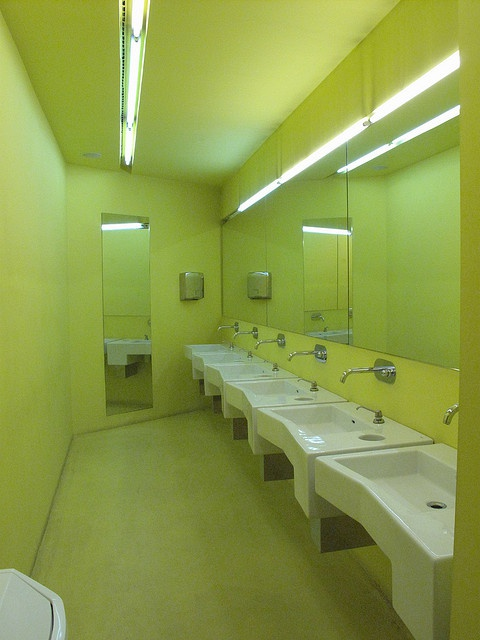Describe the objects in this image and their specific colors. I can see sink in olive and darkgray tones, sink in olive, darkgray, and beige tones, sink in olive, darkgray, and darkgreen tones, sink in olive and darkgray tones, and sink in olive and darkgreen tones in this image. 